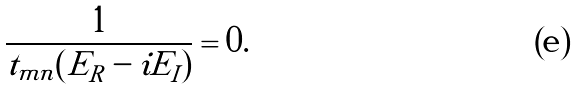Convert formula to latex. <formula><loc_0><loc_0><loc_500><loc_500>\frac { 1 } { t _ { m n } ( E _ { R } - i E _ { I } ) } = 0 .</formula> 